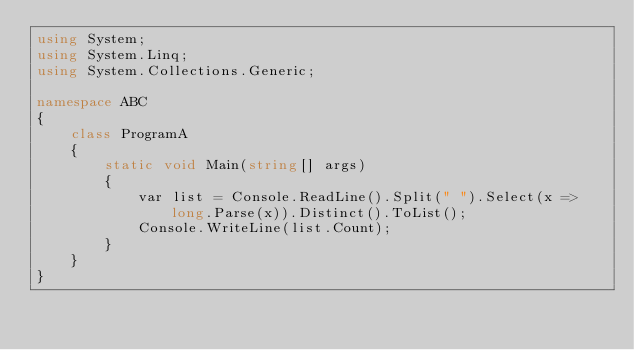<code> <loc_0><loc_0><loc_500><loc_500><_C#_>using System;
using System.Linq;
using System.Collections.Generic;

namespace ABC
{
    class ProgramA
    {
        static void Main(string[] args)
        {
            var list = Console.ReadLine().Split(" ").Select(x => long.Parse(x)).Distinct().ToList();
            Console.WriteLine(list.Count);
        }
    }
}
</code> 